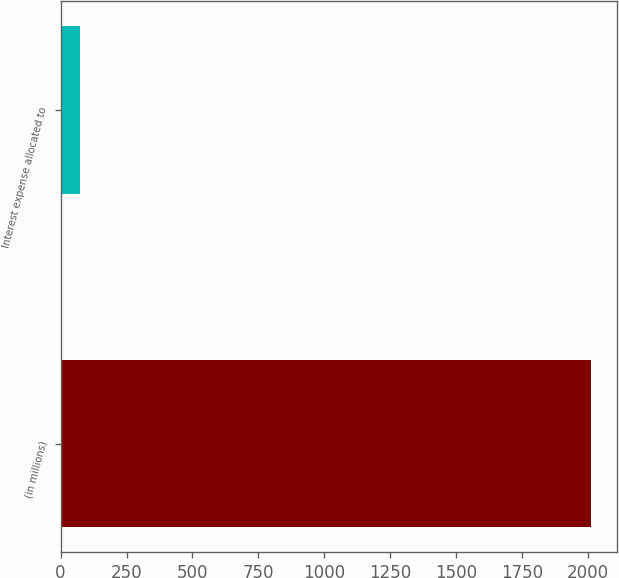Convert chart to OTSL. <chart><loc_0><loc_0><loc_500><loc_500><bar_chart><fcel>(in millions)<fcel>Interest expense allocated to<nl><fcel>2009<fcel>75.2<nl></chart> 